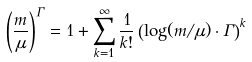Convert formula to latex. <formula><loc_0><loc_0><loc_500><loc_500>\left ( \frac { m } { \mu } \right ) ^ { \Gamma } = 1 + \sum _ { k = 1 } ^ { \infty } \frac { 1 } { k ! } \left ( \log ( m / \mu ) \cdot \Gamma \right ) ^ { k }</formula> 